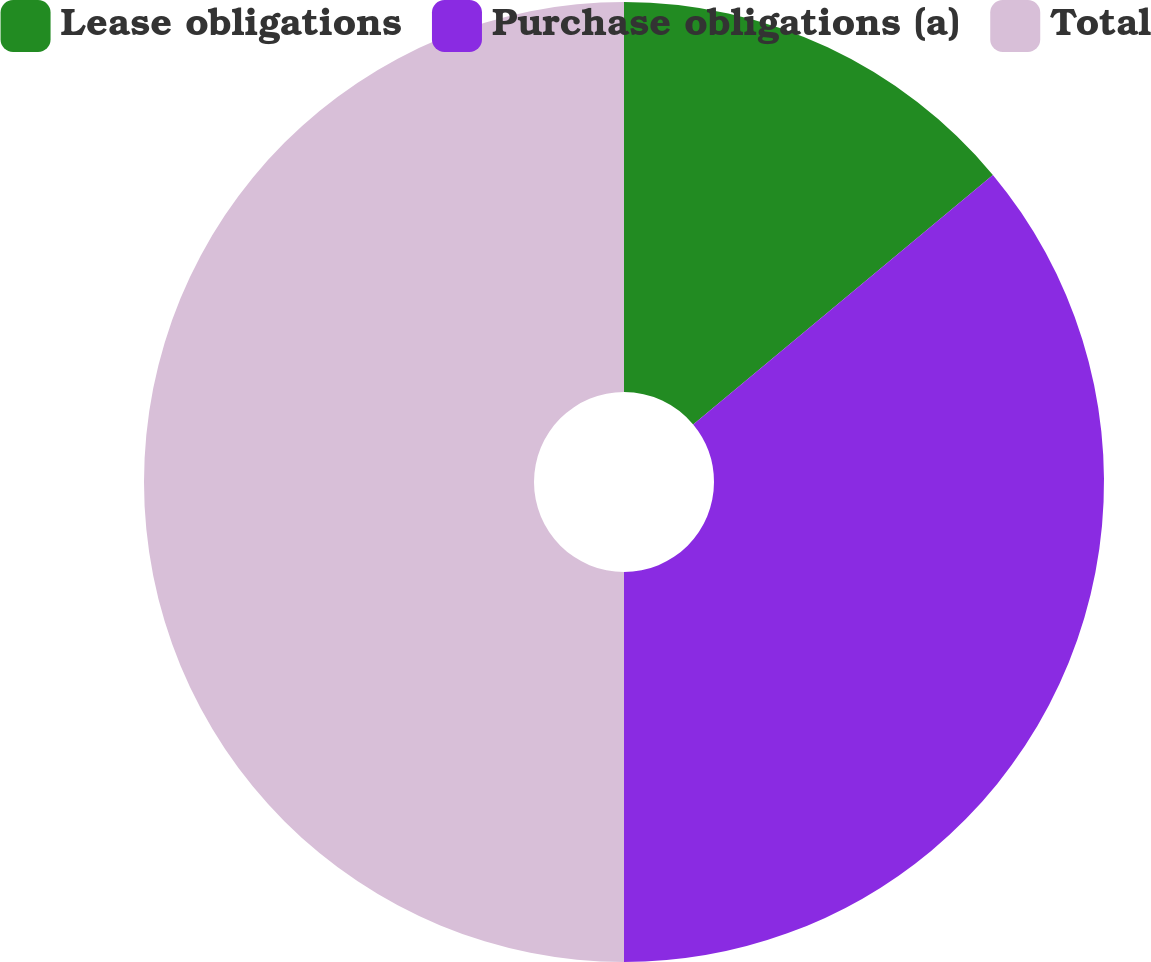Convert chart to OTSL. <chart><loc_0><loc_0><loc_500><loc_500><pie_chart><fcel>Lease obligations<fcel>Purchase obligations (a)<fcel>Total<nl><fcel>13.95%<fcel>36.05%<fcel>50.0%<nl></chart> 